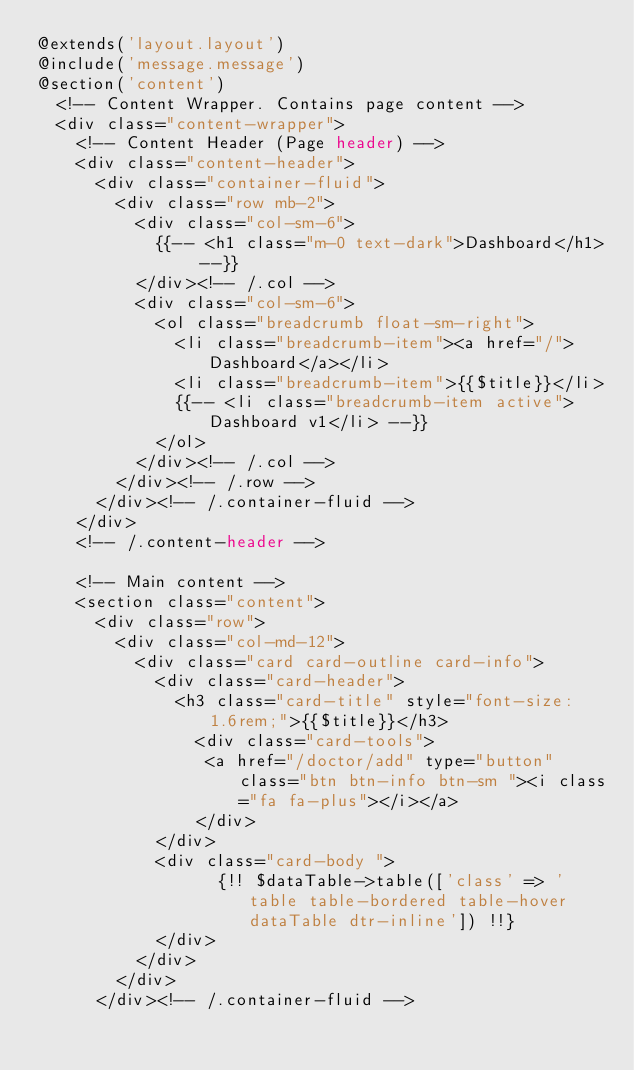<code> <loc_0><loc_0><loc_500><loc_500><_PHP_>@extends('layout.layout')
@include('message.message')
@section('content')
  <!-- Content Wrapper. Contains page content -->
  <div class="content-wrapper">
    <!-- Content Header (Page header) -->
    <div class="content-header">
      <div class="container-fluid">
        <div class="row mb-2">
          <div class="col-sm-6">
            {{-- <h1 class="m-0 text-dark">Dashboard</h1> --}}
          </div><!-- /.col -->
          <div class="col-sm-6">
            <ol class="breadcrumb float-sm-right">
              <li class="breadcrumb-item"><a href="/">Dashboard</a></li>
              <li class="breadcrumb-item">{{$title}}</li>
              {{-- <li class="breadcrumb-item active">Dashboard v1</li> --}}
            </ol>
          </div><!-- /.col -->
        </div><!-- /.row -->
      </div><!-- /.container-fluid -->
    </div>
    <!-- /.content-header -->
    
    <!-- Main content -->
    <section class="content">
      <div class="row">
        <div class="col-md-12">
          <div class="card card-outline card-info">
            <div class="card-header">
              <h3 class="card-title" style="font-size: 1.6rem;">{{$title}}</h3>
                <div class="card-tools">
                 <a href="/doctor/add" type="button" class="btn btn-info btn-sm "><i class="fa fa-plus"></i></a>
                </div>
            </div>
            <div class="card-body ">
                  {!! $dataTable->table(['class' => 'table table-bordered table-hover dataTable dtr-inline']) !!}
            </div>
          </div>
        </div>
      </div><!-- /.container-fluid --></code> 